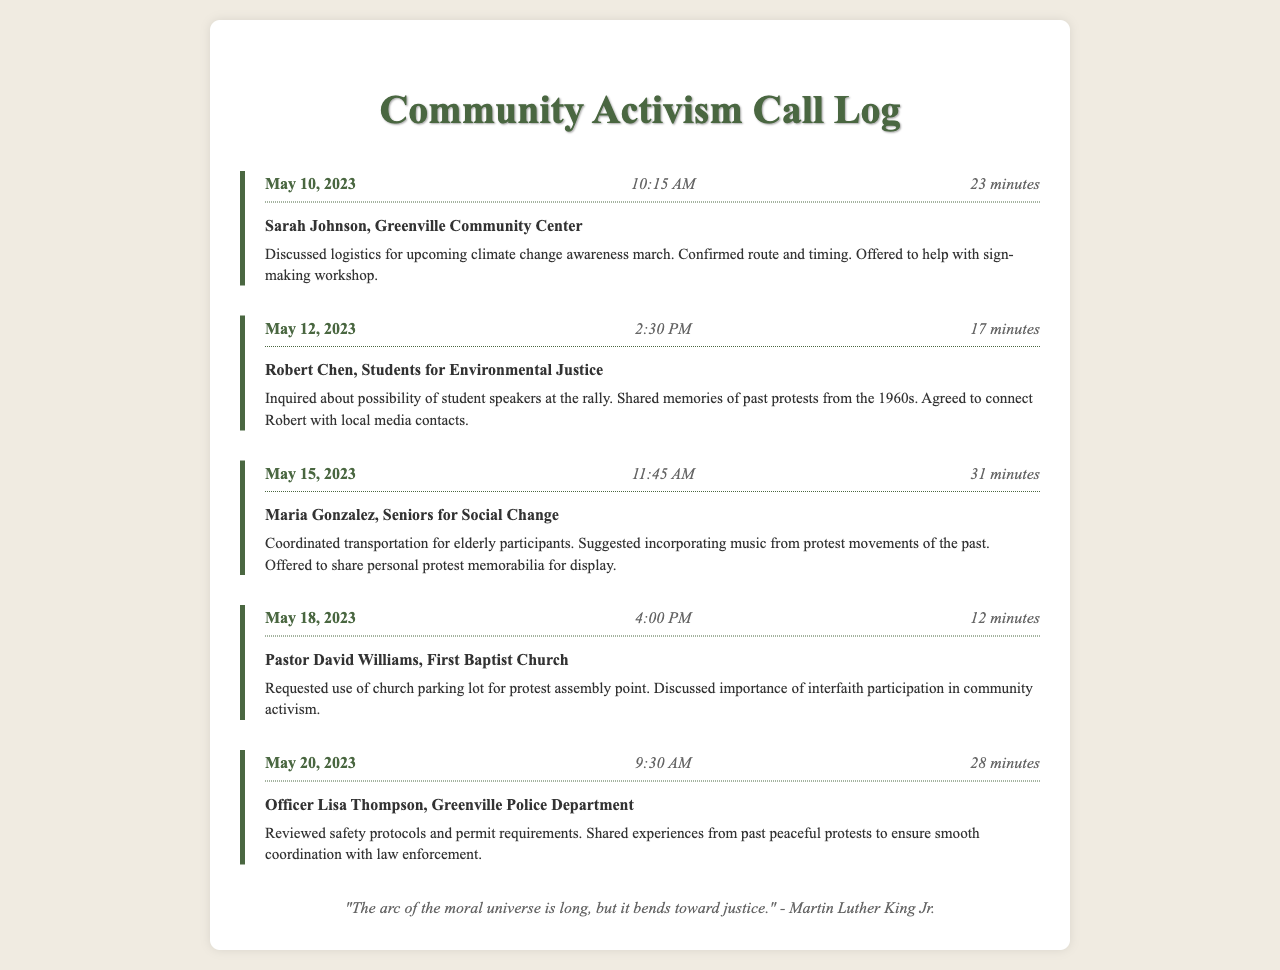What is the date of the first call? The first call is logged on May 10, 2023.
Answer: May 10, 2023 Who did Sarah Johnson call regarding the climate change awareness march? Sarah Johnson, from the Greenville Community Center, discussed logistics for the upcoming march.
Answer: Sarah Johnson What was the duration of the call with Robert Chen? The call with Robert Chen lasted 17 minutes.
Answer: 17 minutes What topic did Maria Gonzalez suggest incorporating into the protest? Maria Gonzalez suggested incorporating music from protest movements of the past.
Answer: Music from protest movements How many minutes was the call with Officer Lisa Thompson? The call with Officer Lisa Thompson lasted 28 minutes.
Answer: 28 minutes What was Pastor David Williams requesting for the protest? Pastor David Williams requested the use of the church parking lot for the protest assembly point.
Answer: Church parking lot Which organization is connected to Robert Chen? Robert Chen is connected to Students for Environmental Justice.
Answer: Students for Environmental Justice What kind of memorabilia did Maria Gonzalez offer to share? Maria Gonzalez offered to share personal protest memorabilia for display.
Answer: Personal protest memorabilia 